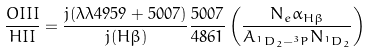<formula> <loc_0><loc_0><loc_500><loc_500>\frac { O I I I } { H I I } = \frac { j ( \lambda \lambda 4 9 5 9 + 5 0 0 7 ) } { j ( H \beta ) } \frac { 5 0 0 7 } { 4 8 6 1 } \left ( \frac { N _ { e } \alpha _ { H \beta } } { A _ { ^ { 1 } D _ { 2 } - ^ { 3 } P } N _ { ^ { 1 } D _ { 2 } } } \right )</formula> 